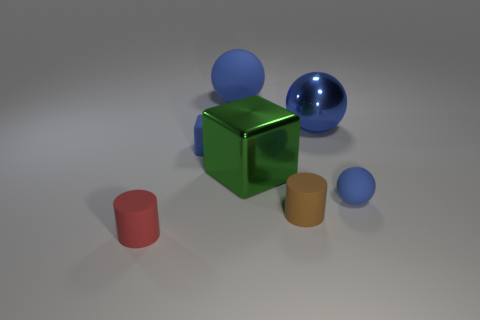What number of objects are either rubber things in front of the tiny blue sphere or cyan shiny cubes?
Offer a very short reply. 2. What shape is the big object that is the same color as the shiny ball?
Provide a short and direct response. Sphere. What material is the cylinder behind the cylinder on the left side of the tiny brown rubber cylinder?
Your response must be concise. Rubber. Are there any tiny cylinders made of the same material as the small red thing?
Keep it short and to the point. Yes. Is there a large blue metal thing that is in front of the tiny blue object that is to the left of the big rubber thing?
Keep it short and to the point. No. What is the material of the tiny object that is behind the small matte ball?
Your answer should be very brief. Rubber. Is the tiny red matte object the same shape as the blue metallic thing?
Your answer should be very brief. No. The rubber sphere that is behind the blue rubber object that is in front of the block to the right of the big rubber ball is what color?
Your answer should be compact. Blue. How many large green shiny things are the same shape as the tiny brown thing?
Give a very brief answer. 0. How big is the cylinder on the left side of the big sphere behind the big blue metal object?
Give a very brief answer. Small. 